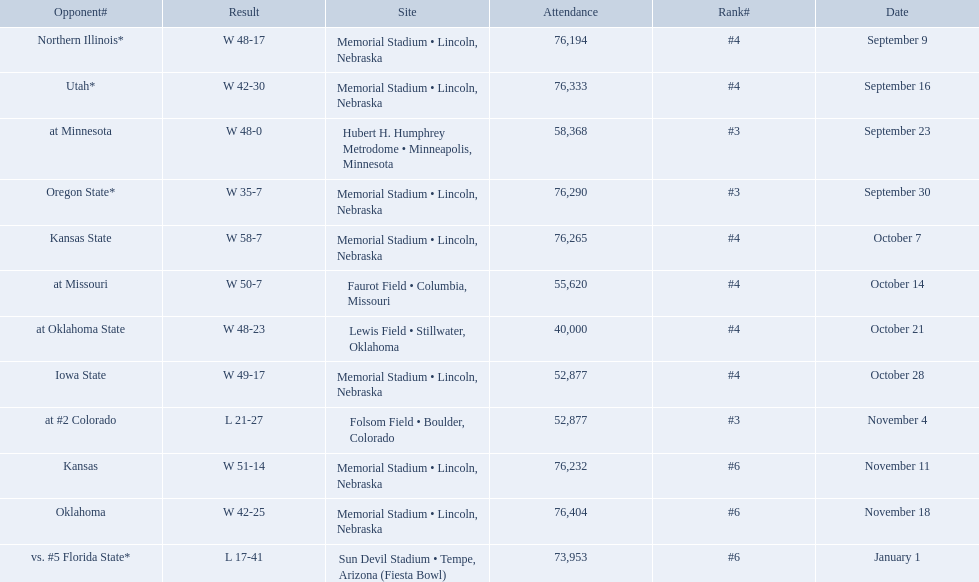Who were all of their opponents? Northern Illinois*, Utah*, at Minnesota, Oregon State*, Kansas State, at Missouri, at Oklahoma State, Iowa State, at #2 Colorado, Kansas, Oklahoma, vs. #5 Florida State*. And what was the attendance of these games? 76,194, 76,333, 58,368, 76,290, 76,265, 55,620, 40,000, 52,877, 52,877, 76,232, 76,404, 73,953. Of those numbers, which is associated with the oregon state game? 76,290. 